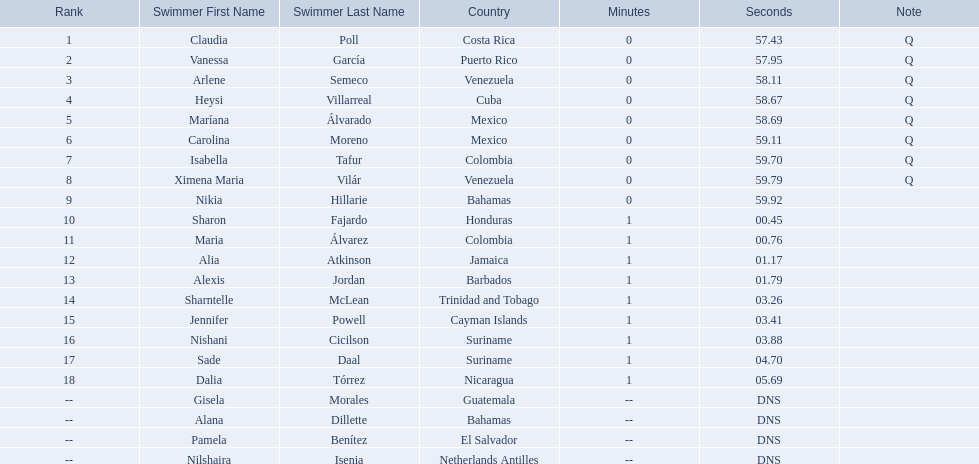Who were all of the swimmers in the women's 100 metre freestyle? Claudia Poll, Vanessa García, Arlene Semeco, Heysi Villarreal, Maríana Álvarado, Carolina Moreno, Isabella Tafur, Ximena Maria Vilár, Nikia Hillarie, Sharon Fajardo, Maria Álvarez, Alia Atkinson, Alexis Jordan, Sharntelle McLean, Jennifer Powell, Nishani Cicilson, Sade Daal, Dalia Tórrez, Gisela Morales, Alana Dillette, Pamela Benítez, Nilshaira Isenia. Where was each swimmer from? Costa Rica, Puerto Rico, Venezuela, Cuba, Mexico, Mexico, Colombia, Venezuela, Bahamas, Honduras, Colombia, Jamaica, Barbados, Trinidad and Tobago, Cayman Islands, Suriname, Suriname, Nicaragua, Guatemala, Bahamas, El Salvador, Netherlands Antilles. What were their ranks? 1, 2, 3, 4, 5, 6, 7, 8, 9, 10, 11, 12, 13, 14, 15, 16, 17, 18, --, --, --, --. Who was in the top eight? Claudia Poll, Vanessa García, Arlene Semeco, Heysi Villarreal, Maríana Álvarado, Carolina Moreno, Isabella Tafur, Ximena Maria Vilár. Of those swimmers, which one was from cuba? Heysi Villarreal. 